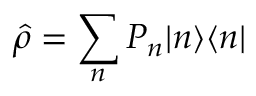Convert formula to latex. <formula><loc_0><loc_0><loc_500><loc_500>\hat { \rho } = \sum _ { n } P _ { n } | n \rangle \langle n |</formula> 